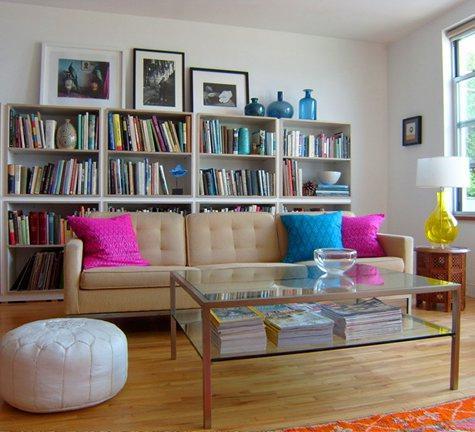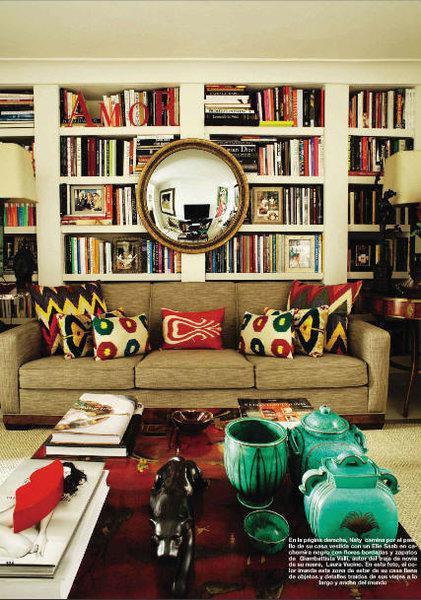The first image is the image on the left, the second image is the image on the right. Examine the images to the left and right. Is the description "The bookshelf in the image on the left is near a window." accurate? Answer yes or no. Yes. The first image is the image on the left, the second image is the image on the right. For the images displayed, is the sentence "A room includes a beige couch in front of a white bookcase and behind a coffee table with slender legs." factually correct? Answer yes or no. Yes. 